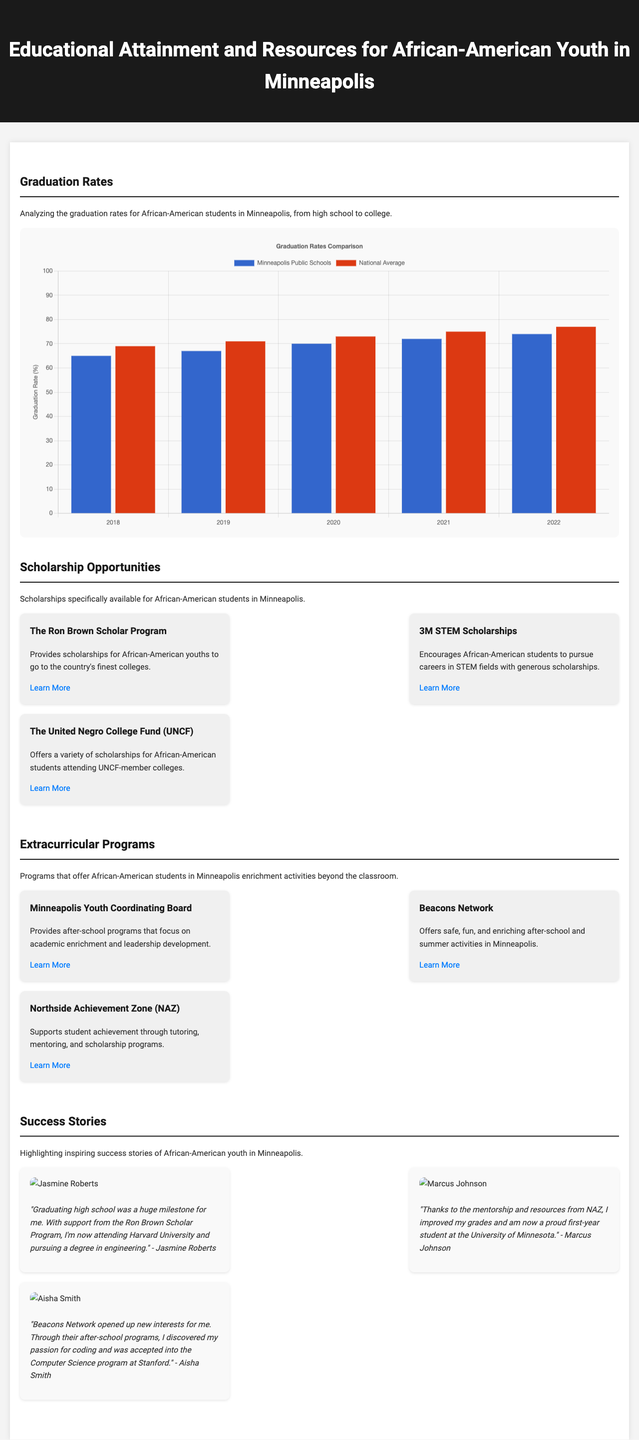What is the highest graduation rate in Minneapolis Public Schools from 2018 to 2022? The highest graduation rate for Minneapolis Public Schools during the years presented is 74%, occurring in 2022.
Answer: 74% What program provides scholarships for African-American youths to attend elite colleges? The program that provides these scholarships is called The Ron Brown Scholar Program.
Answer: The Ron Brown Scholar Program Which year had the lowest graduation rate for the national average? The year with the lowest graduation rate for the national average is 2018, which was 69%.
Answer: 2018 What organization offers after-school programs focused on academic enrichment and leadership development? The organization that offers these programs is the Minneapolis Youth Coordinating Board.
Answer: Minneapolis Youth Coordinating Board What was the graduation rate for Minneapolis Public Schools in 2020? The graduation rate for Minneapolis Public Schools in 2020 was 70%.
Answer: 70% Which scholarship is specifically geared toward encouraging STEM careers? The scholarship geared toward encouraging STEM careers is the 3M STEM Scholarships.
Answer: 3M STEM Scholarships What is the primary focus of Northside Achievement Zone? The primary focus of Northside Achievement Zone is to support student achievement through tutoring, mentoring, and scholarship programs.
Answer: Tutoring, mentoring, and scholarship programs How many success stories are highlighted in the document? The document highlights three success stories of African-American youth.
Answer: Three What year is quoted in Jasmine Roberts' testimonial for her scholarship program? Jasmine Roberts' testimonial references her experience after graduating high school and attending Harvard University, though it does not specify a year.
Answer: Not specified 